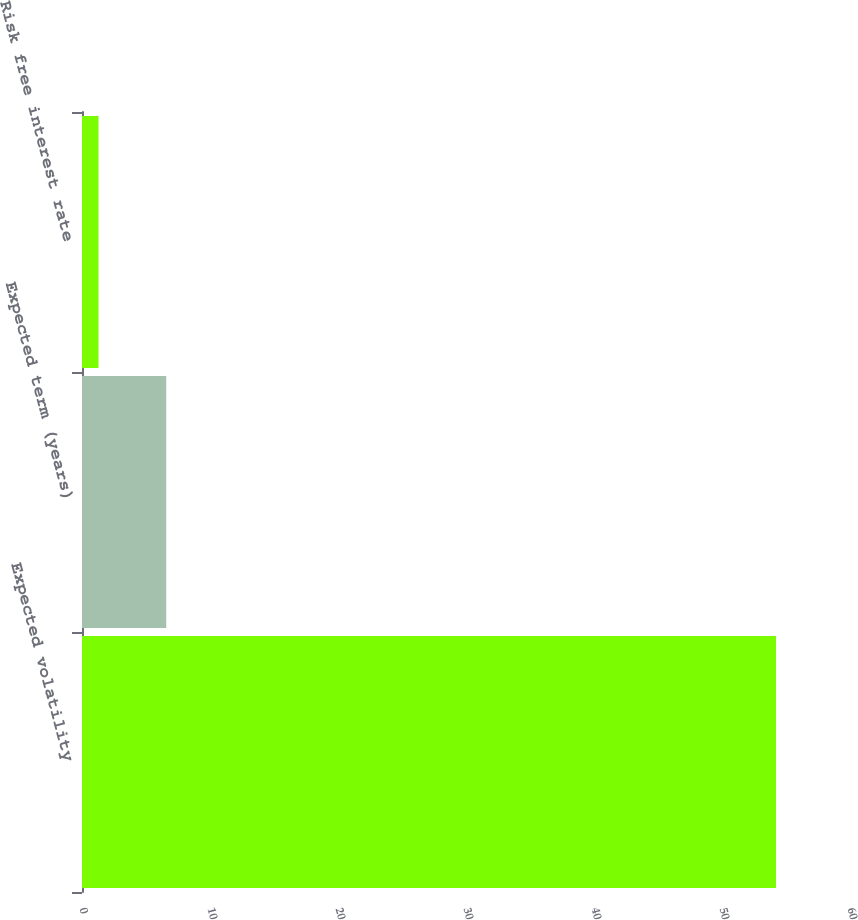Convert chart. <chart><loc_0><loc_0><loc_500><loc_500><bar_chart><fcel>Expected volatility<fcel>Expected term (years)<fcel>Risk free interest rate<nl><fcel>54.22<fcel>6.58<fcel>1.29<nl></chart> 